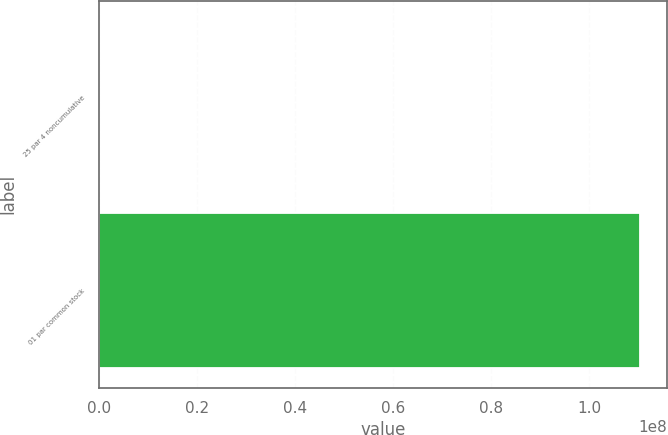Convert chart to OTSL. <chart><loc_0><loc_0><loc_500><loc_500><bar_chart><fcel>25 par 4 noncumulative<fcel>01 par common stock<nl><fcel>242170<fcel>1.10392e+08<nl></chart> 